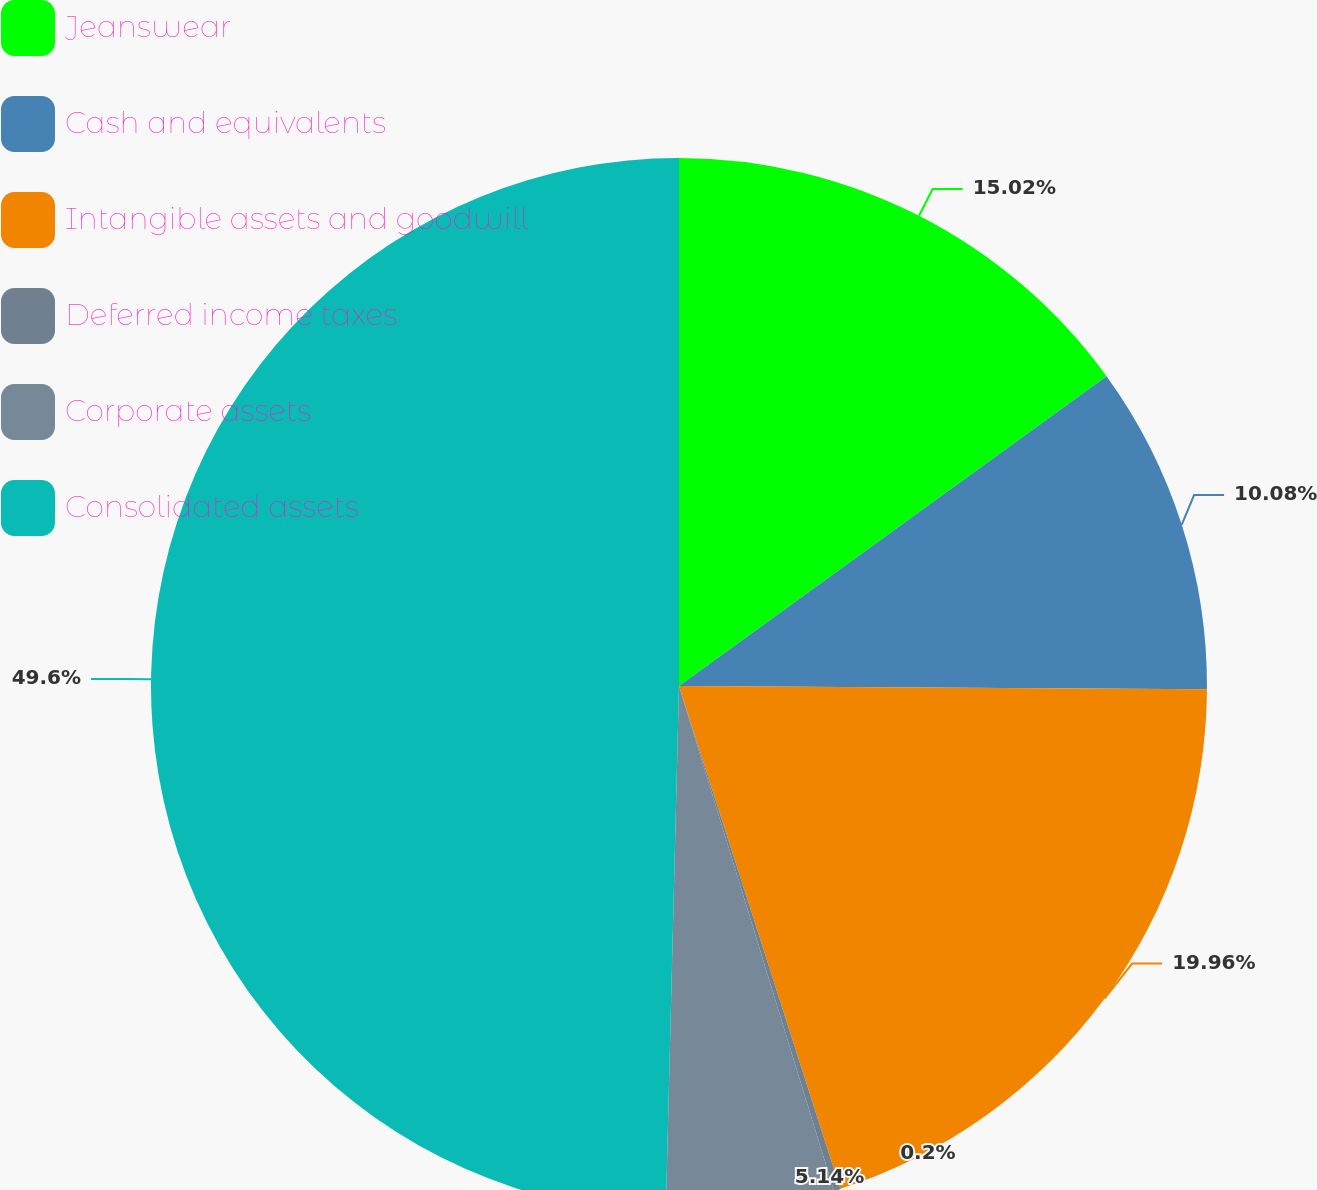Convert chart. <chart><loc_0><loc_0><loc_500><loc_500><pie_chart><fcel>Jeanswear<fcel>Cash and equivalents<fcel>Intangible assets and goodwill<fcel>Deferred income taxes<fcel>Corporate assets<fcel>Consolidated assets<nl><fcel>15.02%<fcel>10.08%<fcel>19.96%<fcel>0.2%<fcel>5.14%<fcel>49.6%<nl></chart> 